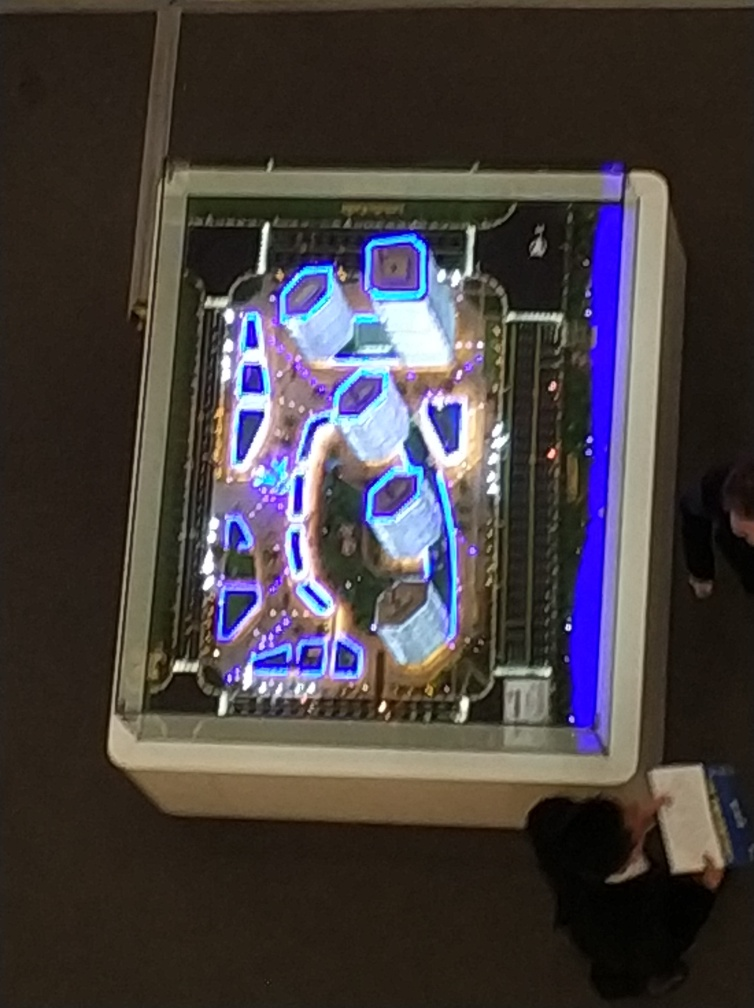What is the brightly lit structure in the image? The image features an overhead view of a visually enticing, lit-up pattern that appears to be either part of an art installation or a uniquely designed public space. Can you describe the colors seen in the image? Certainly, the image is aglow with cool tones, dominating with blues and purples, which give the space an almost futuristic ambiance. 